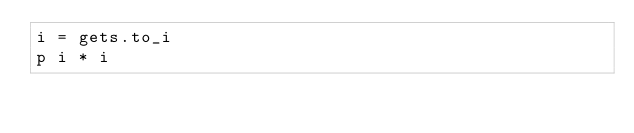Convert code to text. <code><loc_0><loc_0><loc_500><loc_500><_Ruby_>i = gets.to_i
p i * i</code> 